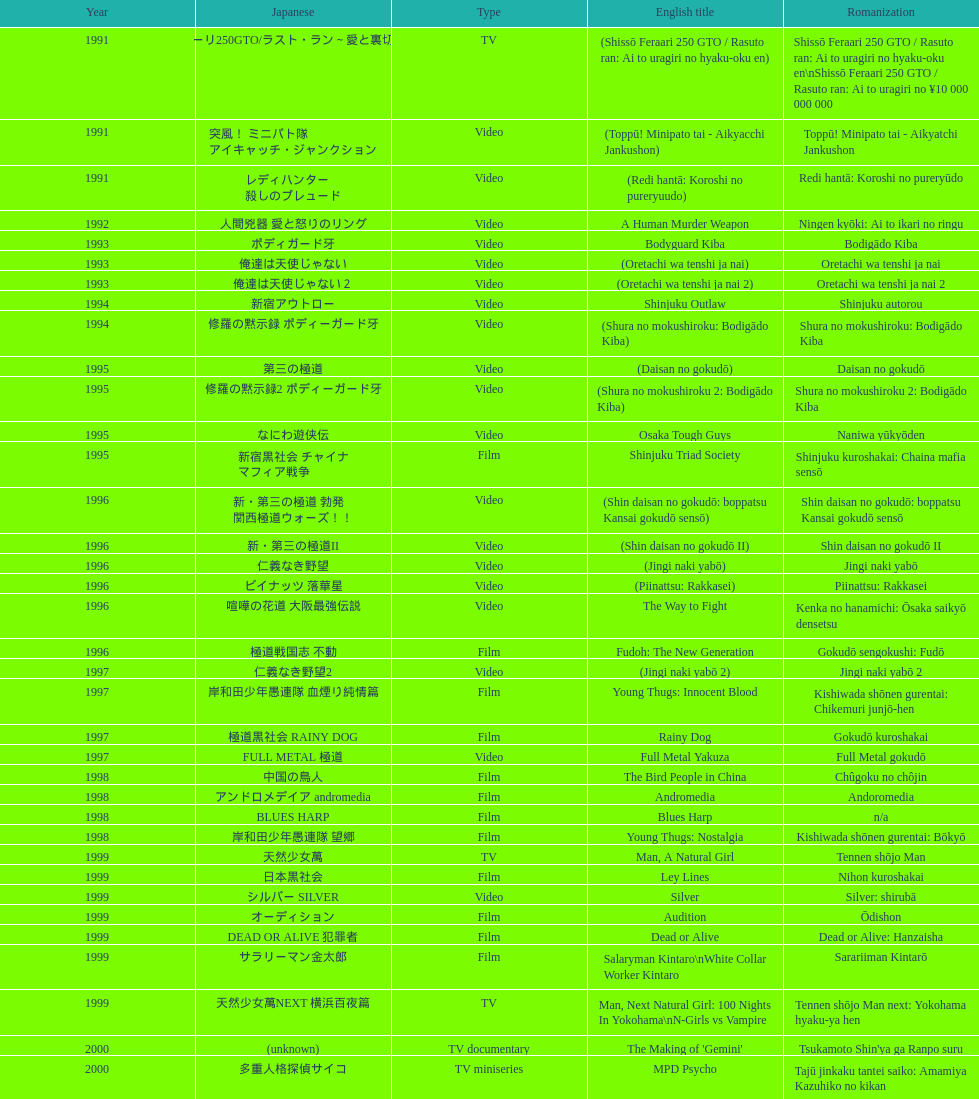How many years is the chart for? 23. 